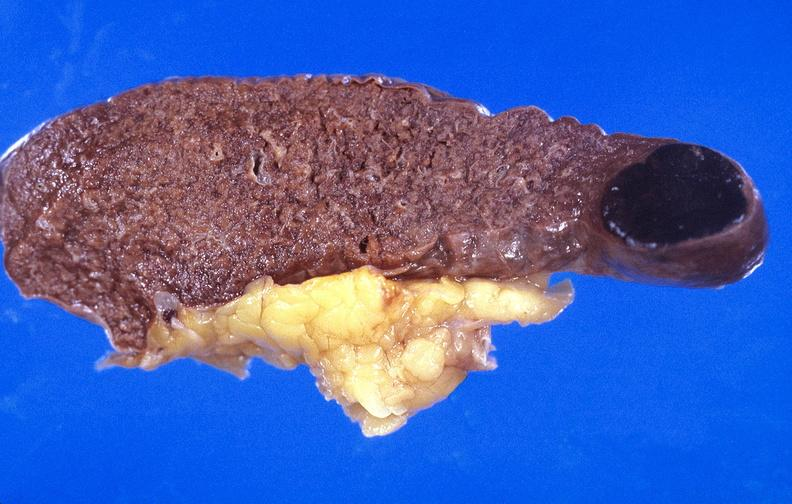what is present?
Answer the question using a single word or phrase. Hematologic 